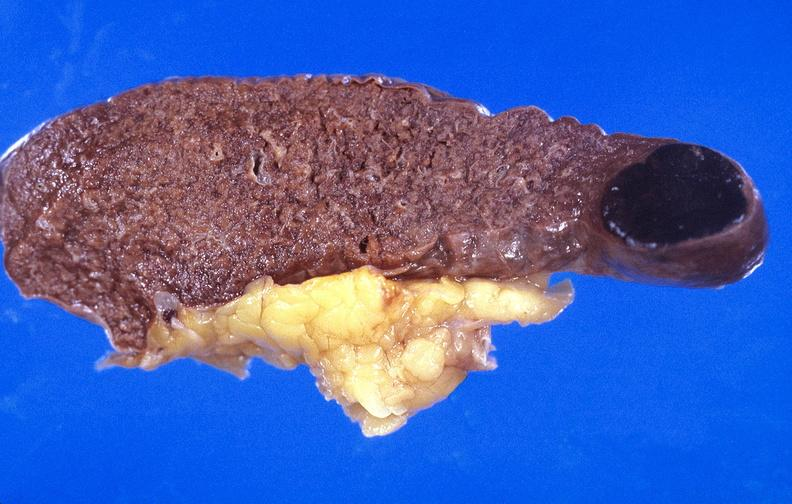what is present?
Answer the question using a single word or phrase. Hematologic 